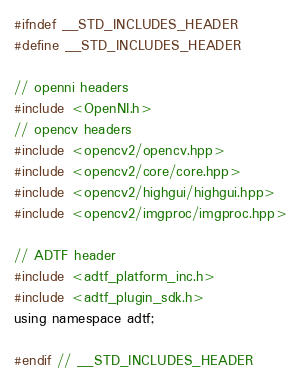Convert code to text. <code><loc_0><loc_0><loc_500><loc_500><_C_>#ifndef __STD_INCLUDES_HEADER
#define __STD_INCLUDES_HEADER

// openni headers
#include <OpenNI.h>
// opencv headers
#include <opencv2/opencv.hpp>
#include <opencv2/core/core.hpp>
#include <opencv2/highgui/highgui.hpp>
#include <opencv2/imgproc/imgproc.hpp>

// ADTF header
#include <adtf_platform_inc.h>
#include <adtf_plugin_sdk.h>
using namespace adtf;

#endif // __STD_INCLUDES_HEADER
</code> 